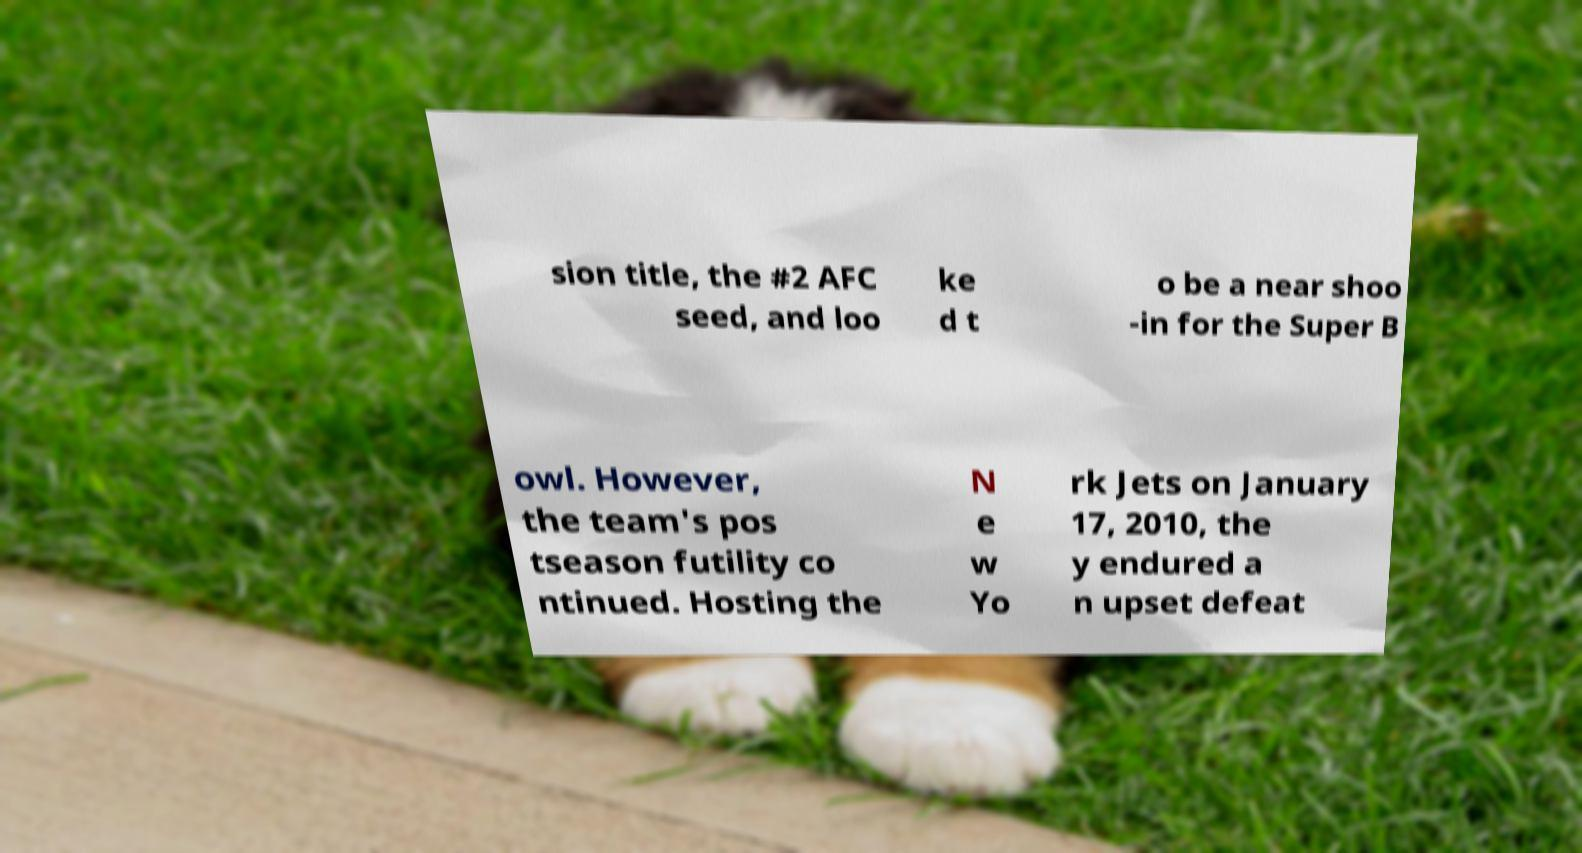Please read and relay the text visible in this image. What does it say? sion title, the #2 AFC seed, and loo ke d t o be a near shoo -in for the Super B owl. However, the team's pos tseason futility co ntinued. Hosting the N e w Yo rk Jets on January 17, 2010, the y endured a n upset defeat 